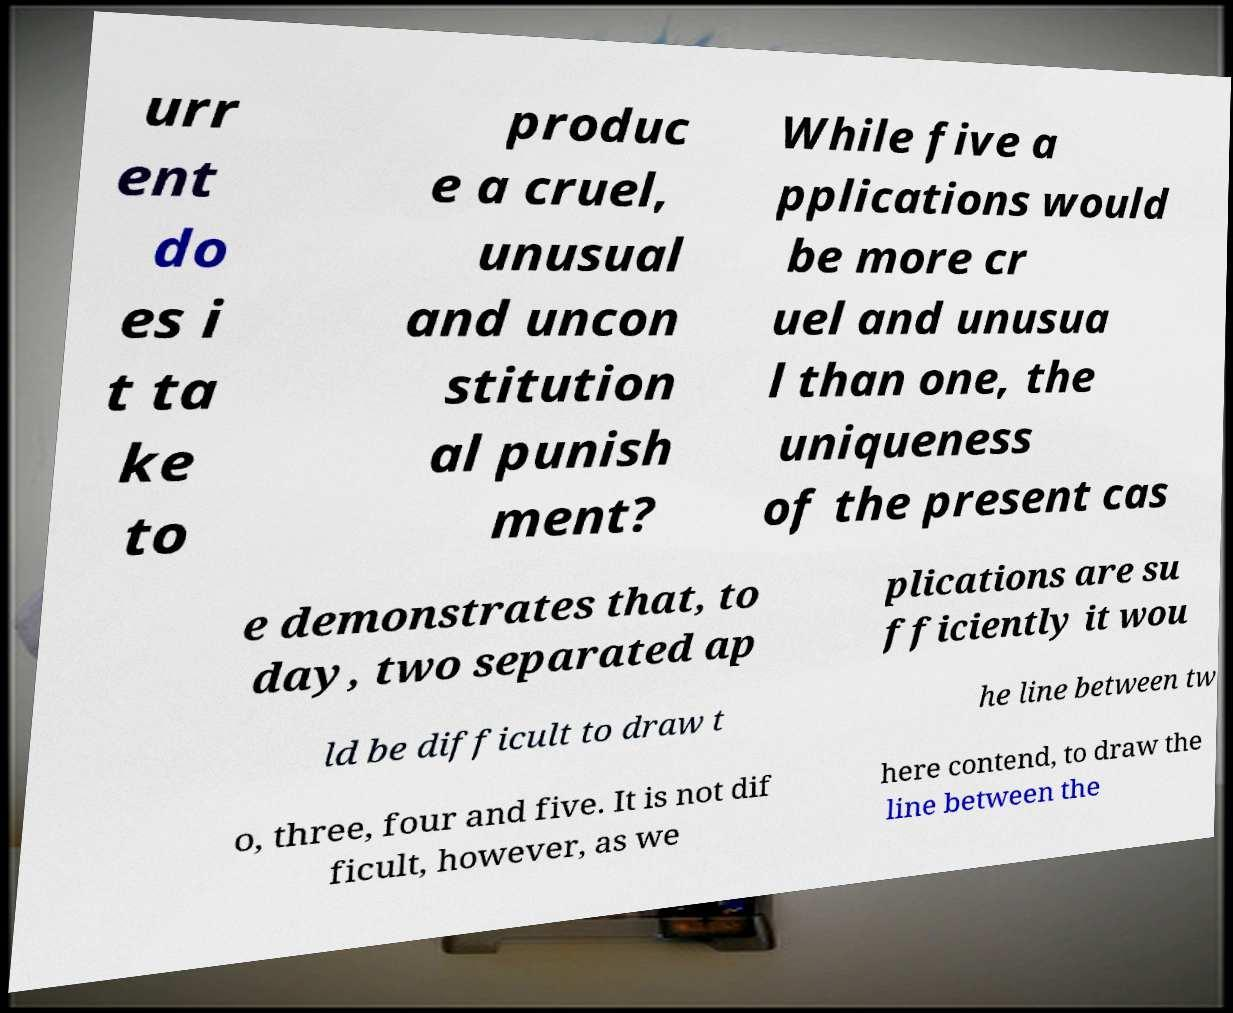Can you read and provide the text displayed in the image?This photo seems to have some interesting text. Can you extract and type it out for me? urr ent do es i t ta ke to produc e a cruel, unusual and uncon stitution al punish ment? While five a pplications would be more cr uel and unusua l than one, the uniqueness of the present cas e demonstrates that, to day, two separated ap plications are su fficiently it wou ld be difficult to draw t he line between tw o, three, four and five. It is not dif ficult, however, as we here contend, to draw the line between the 